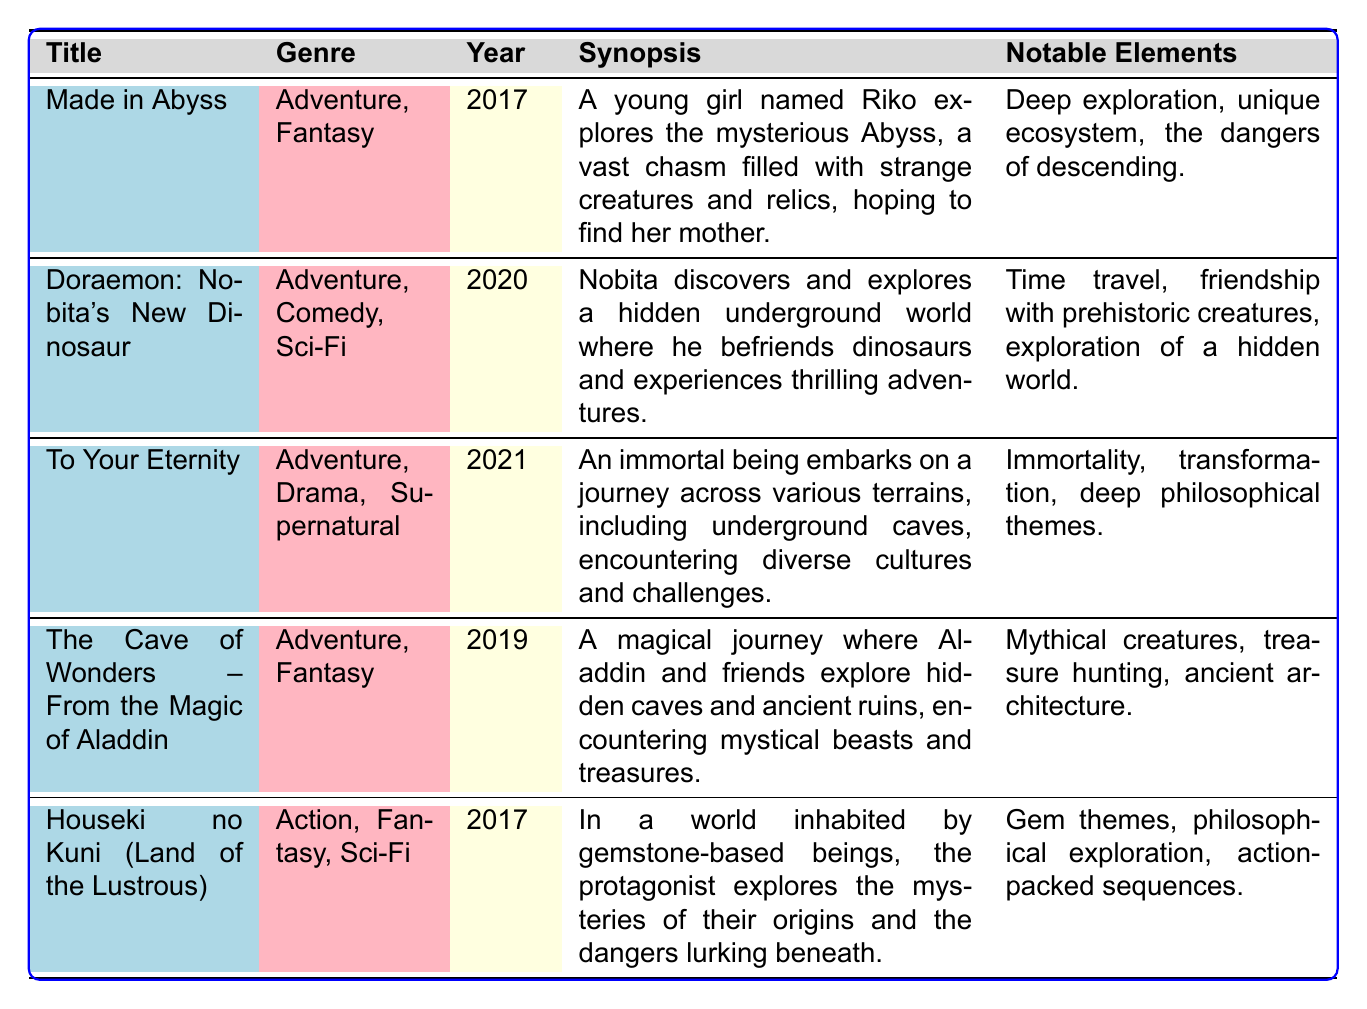What is the title of the anime released in 2021? By scanning the "Year" column in the table, we can find that the title of the anime listed for 2021 is "To Your Eternity."
Answer: To Your Eternity How many anime series in the table have the genre "Adventure"? Reviewing the "Genre" column, we can count the titles. The anime listed as "Adventure" are: "Made in Abyss," "Doraemon: Nobita's New Dinosaur," "To Your Eternity," and "The Cave of Wonders – From the Magic of Aladdin." In total, there are four anime series with the genre "Adventure."
Answer: 4 Is "Houseki no Kuni" categorized as an Action series? Looking at the "Genre" column for "Houseki no Kuni," we see the genres listed are "Action, Fantasy, Sci-Fi." Since "Action" is indeed one of the genres specified, the answer is yes.
Answer: Yes Which anime has a focus on the theme of immortality? Referring to the "Notable Elements" for each anime, "To Your Eternity" is highlighted for its theme of immortality. Therefore, this title is the answer.
Answer: To Your Eternity Which anime series, released in 2017, involves deep exploration? In the "Year" column, "Made in Abyss" and "Houseki no Kuni" are both from 2017. Checking their "Notable Elements," "Made in Abyss" mentions "Deep exploration," so it is the series that fits this description.
Answer: Made in Abyss What is the average release year of the anime series listed in the table? The years of the anime are: 2017, 2020, 2021, 2019, and 2017. To find the average, we first sum these: 2017 + 2020 + 2021 + 2019 + 2017 = 10095. Then, we divide by the number of series, which is 5: 10095 / 5 = 2019.
Answer: 2019 Does any anime in the table feature a hidden underground world? Checking the "Synopsis" for all titles, "Doraemon: Nobita's New Dinosaur" specifically mentions "a hidden underground world," confirming that at least one anime series includes this element.
Answer: Yes Which anime mentions both philosophical exploration and action-packed sequences? Referring to the "Notable Elements" for each anime, "Houseki no Kuni" includes "philosophical exploration" and "action-packed sequences," which are the criteria needed to answer this question.
Answer: Houseki no Kuni 